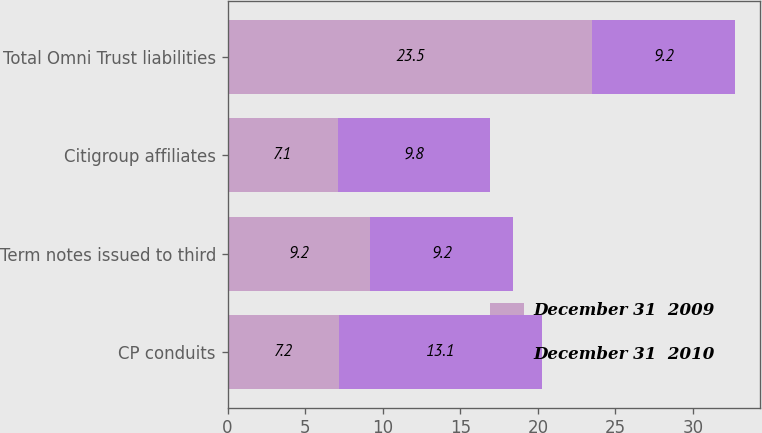Convert chart. <chart><loc_0><loc_0><loc_500><loc_500><stacked_bar_chart><ecel><fcel>CP conduits<fcel>Term notes issued to third<fcel>Citigroup affiliates<fcel>Total Omni Trust liabilities<nl><fcel>December 31  2009<fcel>7.2<fcel>9.2<fcel>7.1<fcel>23.5<nl><fcel>December 31  2010<fcel>13.1<fcel>9.2<fcel>9.8<fcel>9.2<nl></chart> 